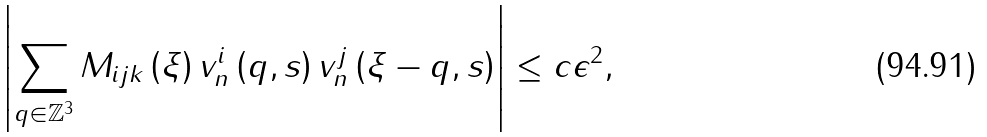<formula> <loc_0><loc_0><loc_500><loc_500>\left | \sum _ { q \in \mathbb { Z } ^ { 3 } } M _ { i j k } \left ( \xi \right ) v _ { n } ^ { i } \left ( q , s \right ) v _ { n } ^ { j } \left ( \xi - q , s \right ) \right | \leq c \epsilon ^ { 2 } ,</formula> 